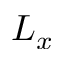<formula> <loc_0><loc_0><loc_500><loc_500>L _ { x }</formula> 